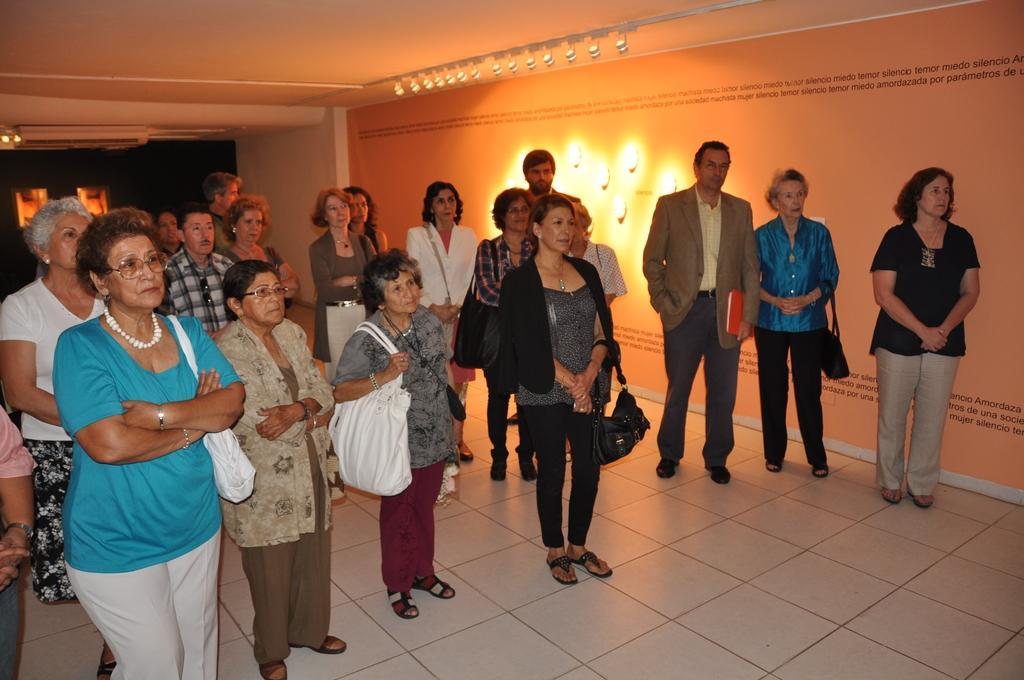Please provide a concise description of this image. In the picture we can see some people are standing on the floor, the floor is with white color tiles and beside them, we can see a wall with a long poster and on it we can see lights and behind them we can see a dark with some part of the light. 